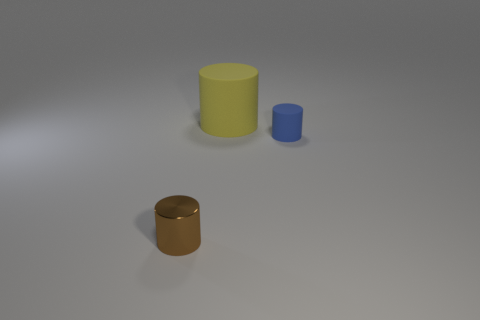Add 3 tiny gray rubber spheres. How many objects exist? 6 Subtract 0 cyan cylinders. How many objects are left? 3 Subtract all small green rubber blocks. Subtract all rubber things. How many objects are left? 1 Add 2 yellow objects. How many yellow objects are left? 3 Add 3 small brown metallic cylinders. How many small brown metallic cylinders exist? 4 